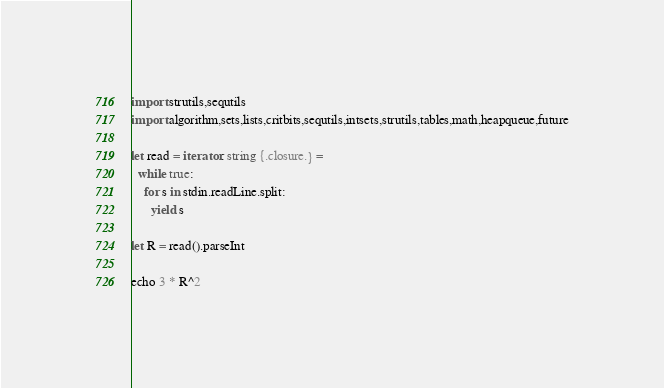Convert code to text. <code><loc_0><loc_0><loc_500><loc_500><_Nim_>import strutils,sequtils
import algorithm,sets,lists,critbits,sequtils,intsets,strutils,tables,math,heapqueue,future

let read = iterator: string {.closure.} =
  while true:
    for s in stdin.readLine.split:
      yield s

let R = read().parseInt

echo 3 * R^2
</code> 